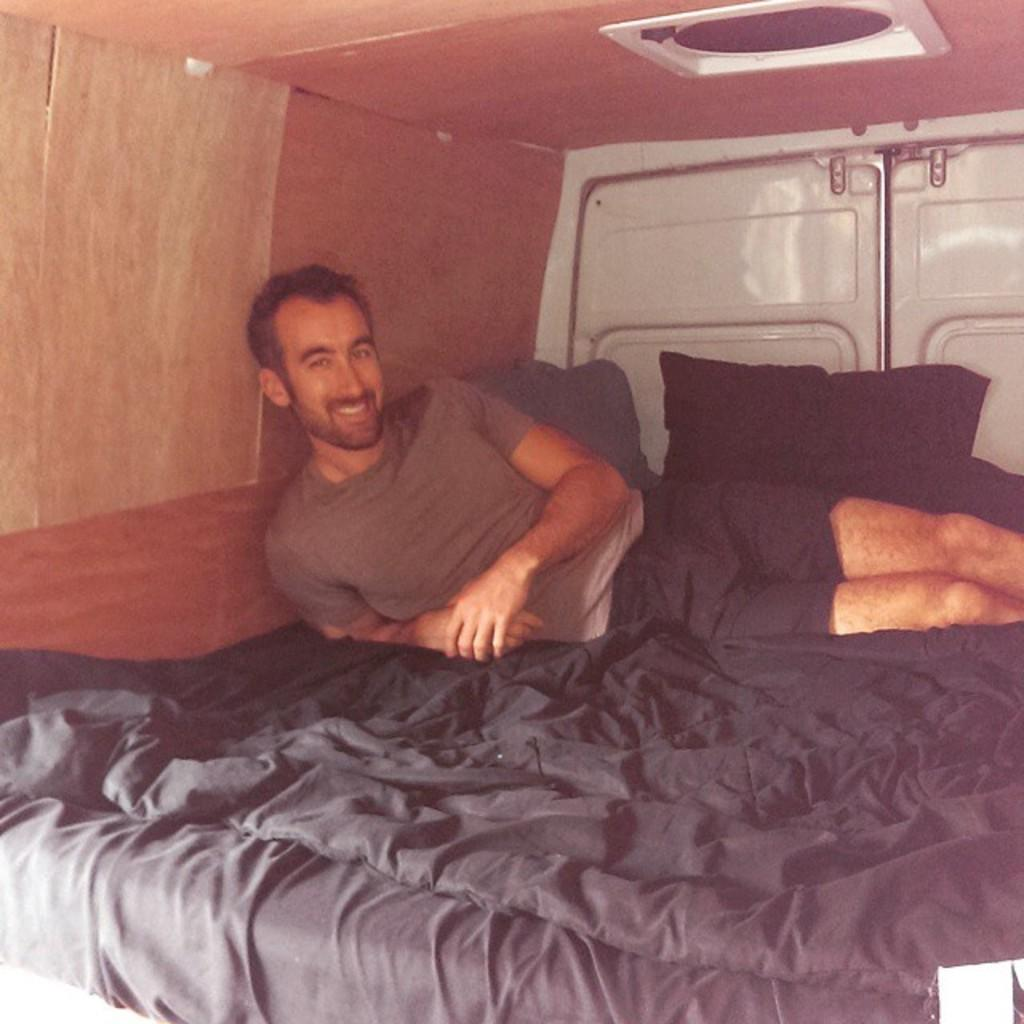What is the main subject of the image? There is a man in the image. What is the man doing in the image? The man is laying on a bed. What is the man wearing in the image? The man is wearing a T-shirt and shorts. What expression does the man have in the image? The man is smiling. What bedding items are present in the image? There is a bed sheet and a pillow in the image. What part of the room can be seen in the image? The roof is visible in the image. What type of light is being used to illuminate the man in the image? There is no specific light source mentioned or visible in the image, so it cannot be determined what type of light is being used. 